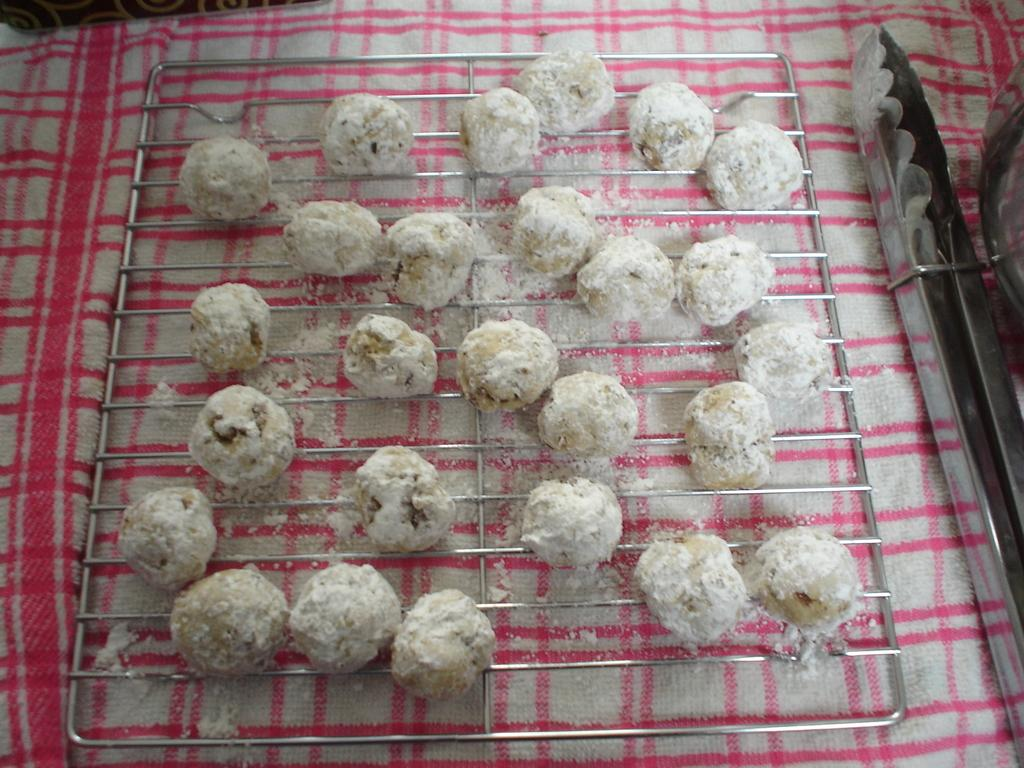What is present on the cloth in the image? There are eatables on the cloth. Can you describe the cloth in the image? The cloth is the surface on which the eatables are placed. Is there a bell ringing in the image? There is no bell or any indication of sound in the image. Can you see a girl playing in the park in the image? There is no girl or park present in the image; it only features a cloth with eatables on it. 